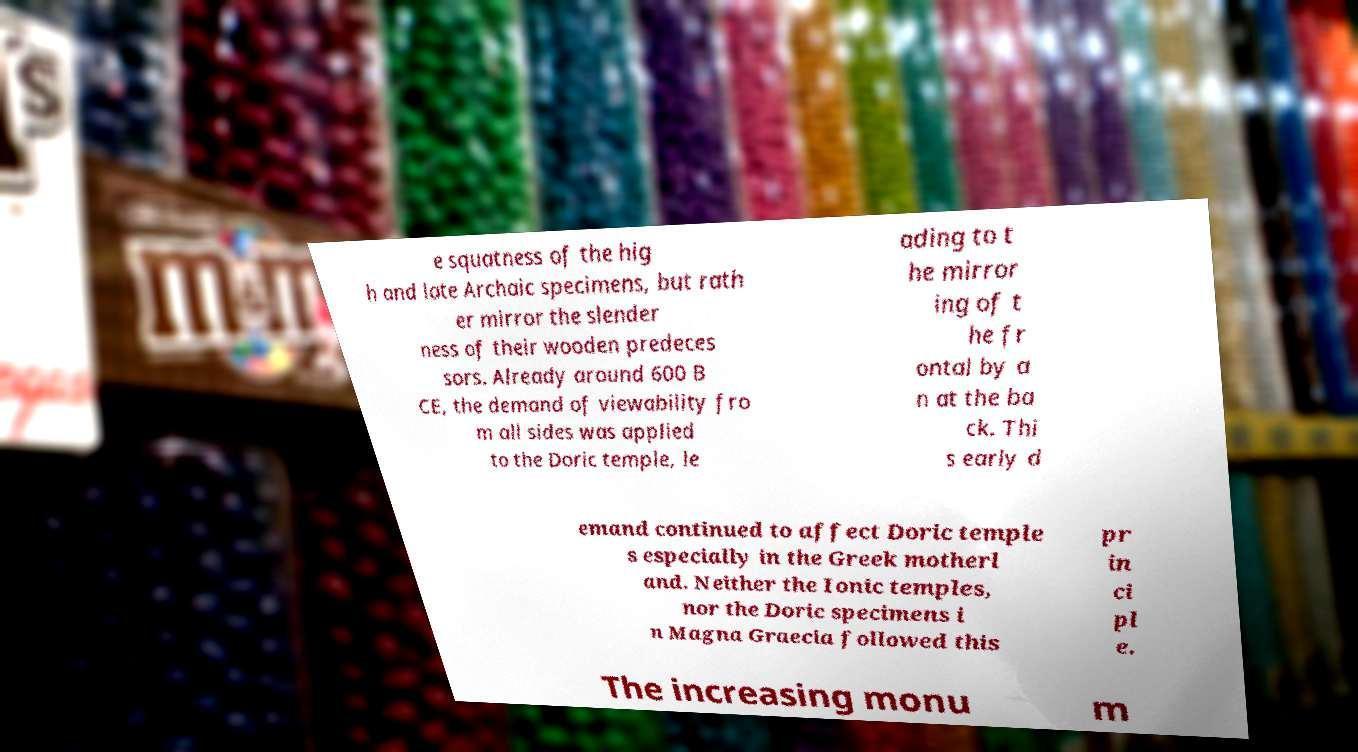What messages or text are displayed in this image? I need them in a readable, typed format. e squatness of the hig h and late Archaic specimens, but rath er mirror the slender ness of their wooden predeces sors. Already around 600 B CE, the demand of viewability fro m all sides was applied to the Doric temple, le ading to t he mirror ing of t he fr ontal by a n at the ba ck. Thi s early d emand continued to affect Doric temple s especially in the Greek motherl and. Neither the Ionic temples, nor the Doric specimens i n Magna Graecia followed this pr in ci pl e. The increasing monu m 